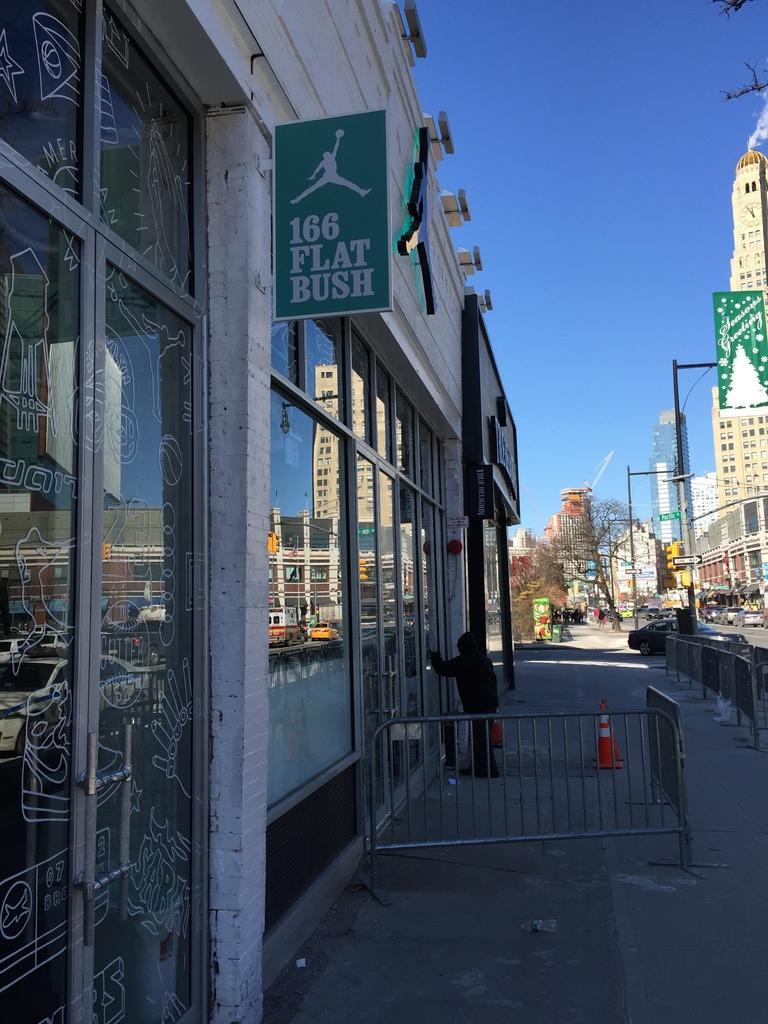Please provide a concise description of this image. In this image we can see the glass doors, fence, a person standing here, we can see road cones, boards, poles, a vehicle moving on the road, buildings, trees and the blue sky in the background. 